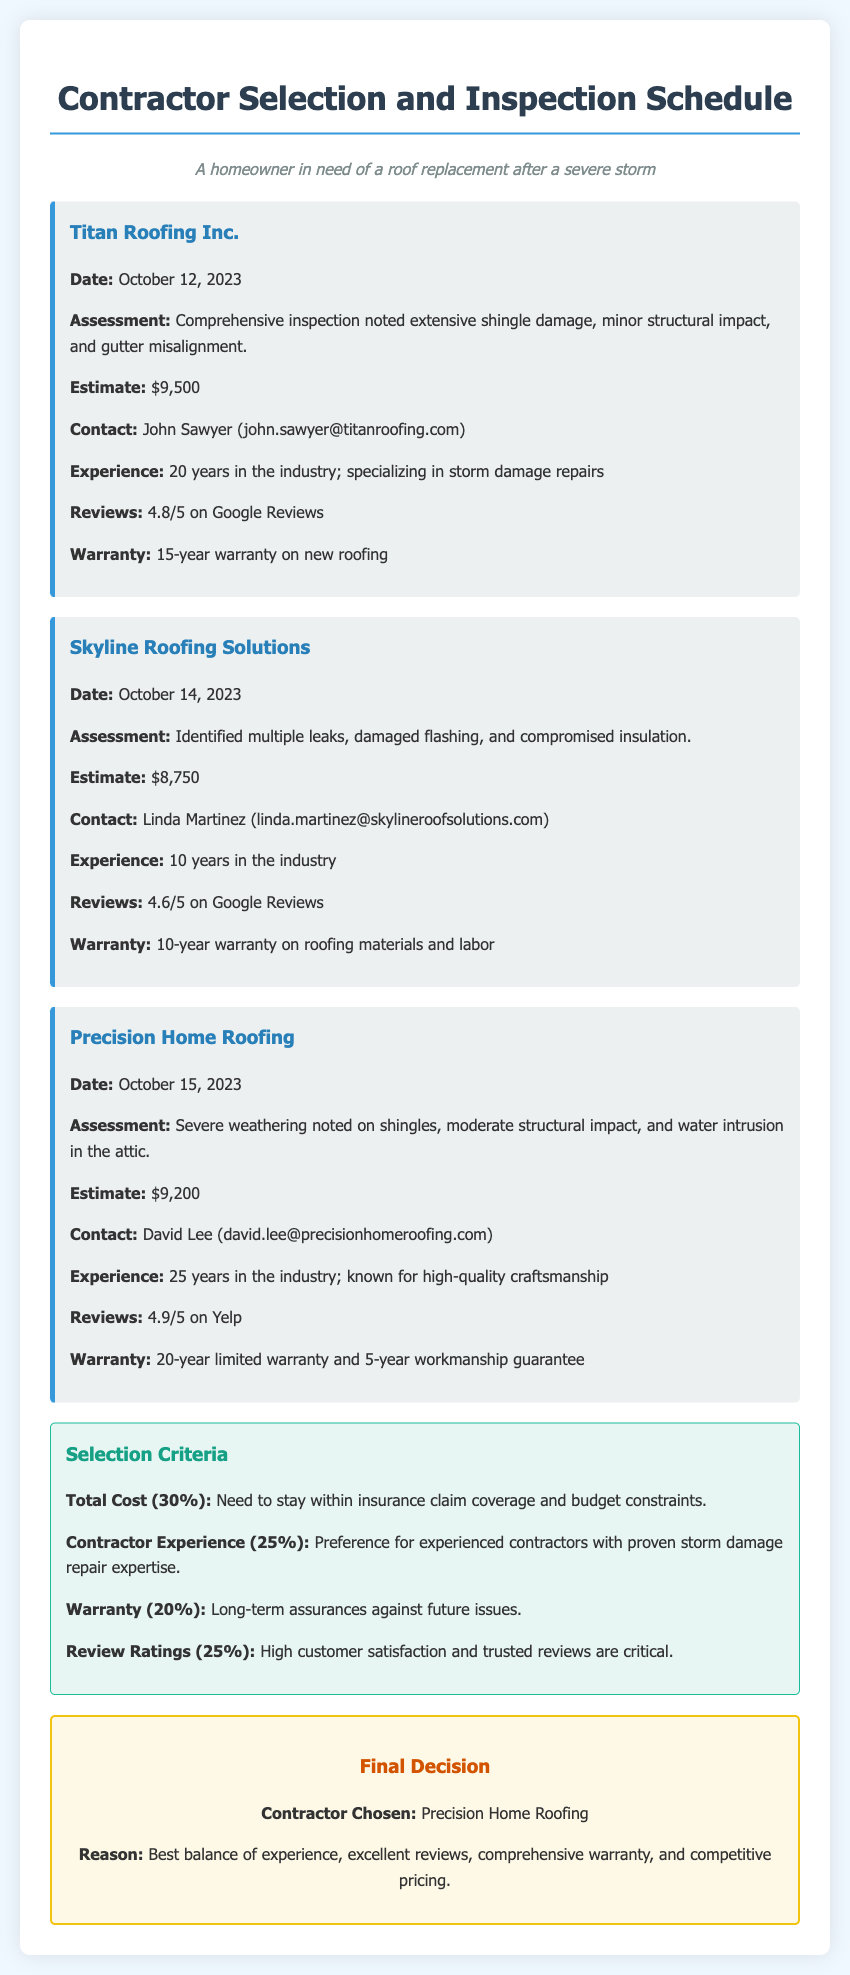What is the name of the contractor with the highest estimate? The contractor with the highest estimate is Titan Roofing Inc. with an estimate of $9,500.
Answer: Titan Roofing Inc What is the date of the appointment with Skyline Roofing Solutions? The date mentioned for the appointment with Skyline Roofing Solutions is October 14, 2023.
Answer: October 14, 2023 How many years of experience does Precision Home Roofing have? Precision Home Roofing has 25 years of experience in the industry.
Answer: 25 years What was the total cost estimate provided by Skyline Roofing Solutions? Skyline Roofing Solutions provided a total cost estimate of $8,750.
Answer: $8,750 Which contractor received the highest customer review rating? The contractor with the highest review rating is Precision Home Roofing with a rating of 4.9/5 on Yelp.
Answer: 4.9/5 What are the criteria for contractor selection? The selection criteria include Total Cost, Contractor Experience, Warranty, and Review Ratings.
Answer: Total Cost, Contractor Experience, Warranty, Review Ratings What is the warranty period offered by Titan Roofing Inc.? Titan Roofing Inc. offers a 15-year warranty on new roofing.
Answer: 15-year Who was chosen as the final contractor for the roof replacement? The final contractor chosen for the roof replacement is Precision Home Roofing.
Answer: Precision Home Roofing What was the reason for choosing Precision Home Roofing? The reason for choosing Precision Home Roofing was the best balance of experience, excellent reviews, comprehensive warranty, and competitive pricing.
Answer: Best balance of experience, excellent reviews, comprehensive warranty, and competitive pricing 